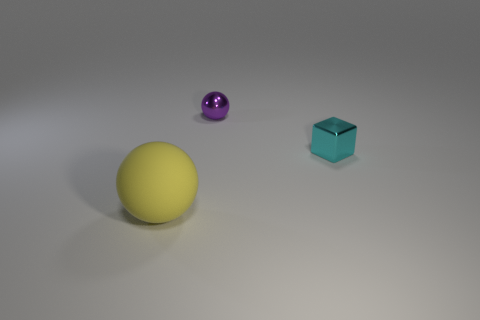Are there any other things that have the same size as the matte sphere?
Provide a succinct answer. No. What number of large yellow matte spheres are in front of the ball behind the cyan cube?
Your answer should be very brief. 1. What number of things are shiny things that are on the left side of the tiny cyan object or big cyan cylinders?
Make the answer very short. 1. Are there any yellow objects of the same shape as the tiny purple object?
Provide a succinct answer. Yes. What is the shape of the small metal object in front of the sphere behind the big rubber thing?
Offer a very short reply. Cube. How many cylinders are small things or tiny purple things?
Offer a terse response. 0. Is the shape of the tiny thing that is on the left side of the cyan block the same as the tiny metal thing that is to the right of the tiny purple ball?
Give a very brief answer. No. What color is the thing that is on the left side of the small block and behind the big sphere?
Give a very brief answer. Purple. There is a thing that is both in front of the small purple ball and on the left side of the tiny cyan cube; how big is it?
Offer a very short reply. Large. What number of other things are the same color as the metallic sphere?
Make the answer very short. 0. 